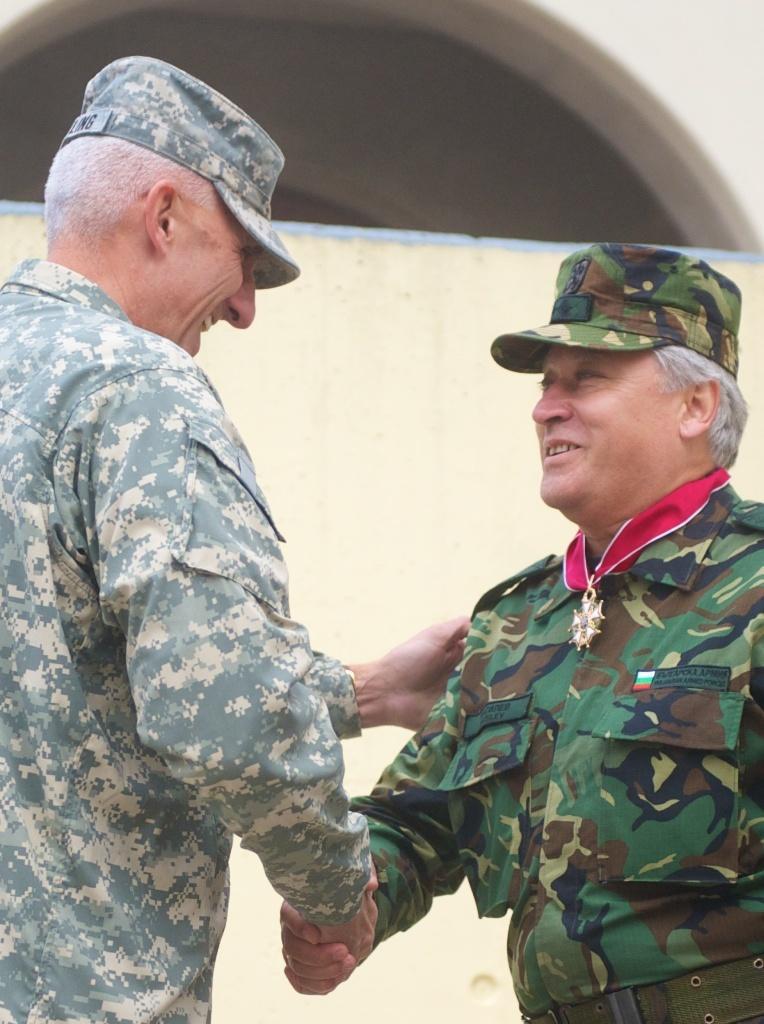Can you describe this image briefly? As we can see in the image in the front there are two people wearing army dresses and hat. In the background there is a building. 